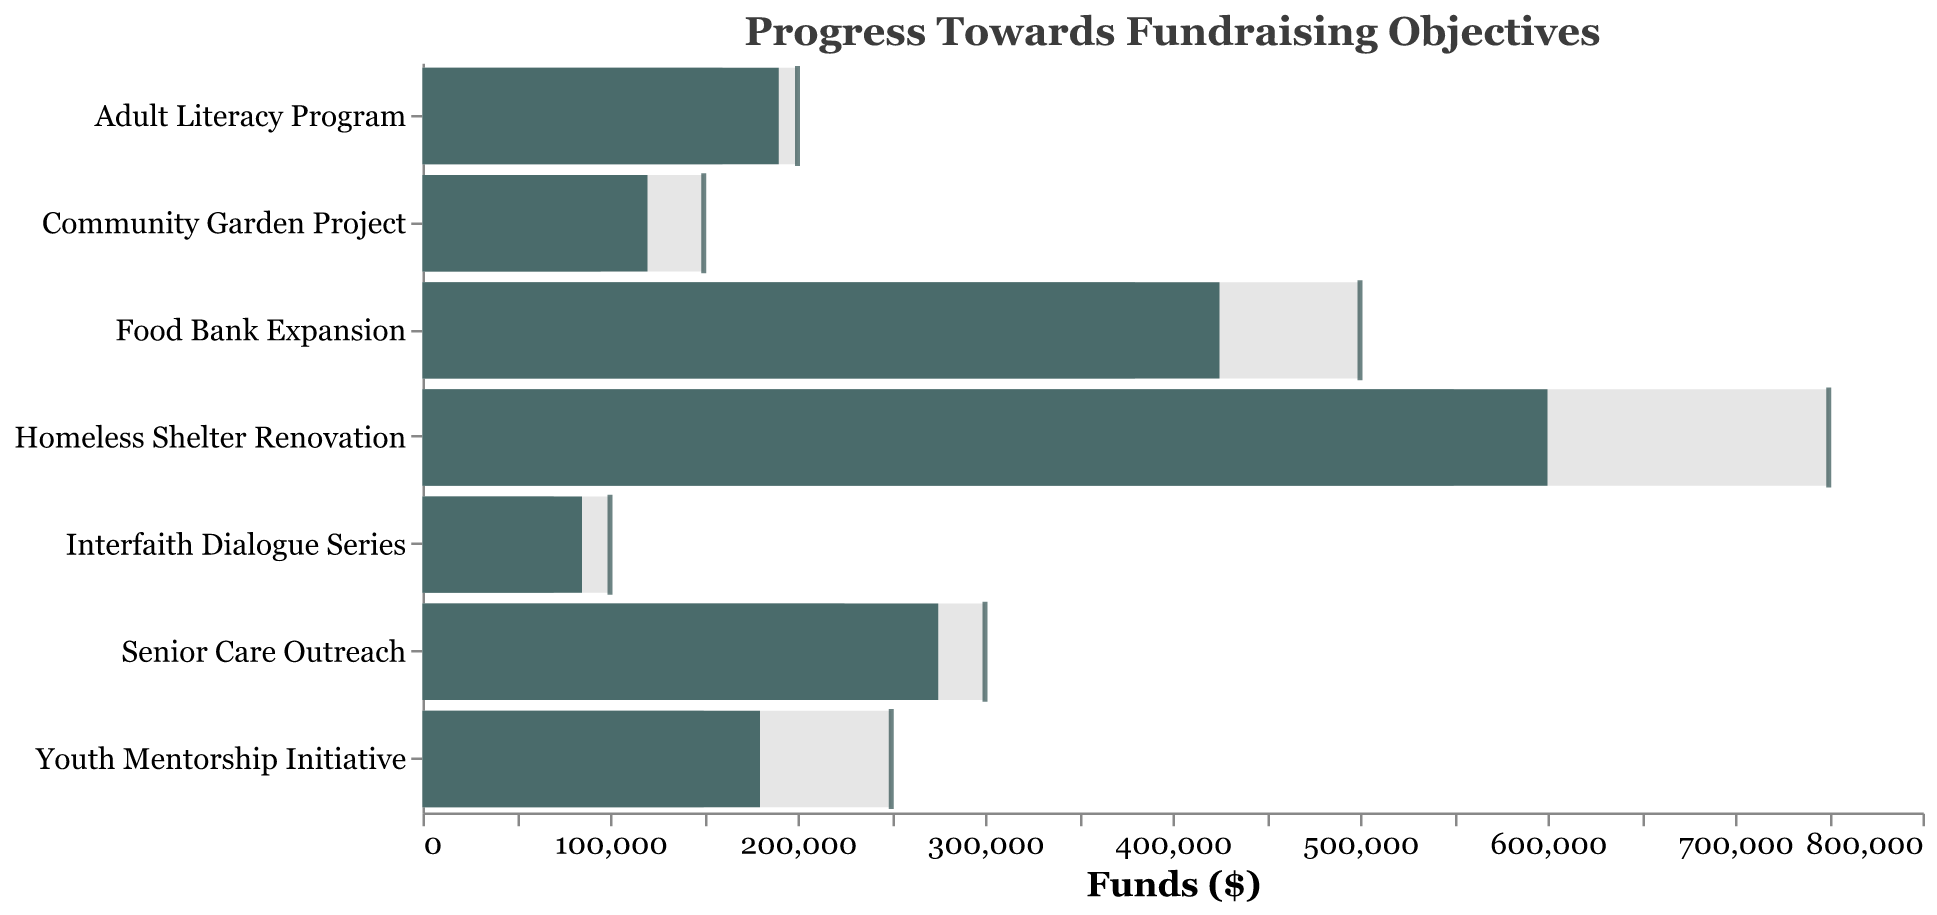What is the title of the chart? The title of the chart is displayed at the top and can be read directly.
Answer: Progress Towards Fundraising Objectives Which program has the highest fundraising target? By looking at the bars and ticks representing the targets, the highest target corresponds to the longest bar.
Answer: Homeless Shelter Renovation How does the current fundraising for the Senior Care Outreach compare to the previous year? The current fundraising amount is represented by the dark bar, while the previous year's amount is represented by the lighter bar.
Answer: Higher Which program is the closest to reaching its fundraising target? By comparing the lengths of the dark bars (current fundraising) to the ticks (targets), the program whose dark bar is closest to the tick is the closest to its target.
Answer: Adult Literacy Program What is the total fundraising target for all programs combined? Add up all the target values from the data provided. 500000 + 250000 + 300000 + 100000 + 750000 + 200000 + 150000 = 2,250,000
Answer: 2,250,000 By how much has the Youth Mentorship Initiative's fundraising increased compared to the previous year? Subtract the previous year's amount from the current amount: 180000 - 150000 = 30000
Answer: 30,000 Which program saw the largest increase in fundraising from the previous year? Compare the increase in each program by subtracting the previous year's amount from the current amount and finding the greatest difference: - Food Bank Expansion: 425000 - 380000 = 45000 - Youth Mentorship Initiative: 180000 - 150000 = 30000 - Senior Care Outreach: 275000 - 225000 = 50000 - Interfaith Dialogue Series: 85000 - 70000 = 15000 - Homeless Shelter Renovation: 600000 - 550000 = 50000 - Adult Literacy Program: 190000 - 160000 = 30000 - Community Garden Project: 120000 - 95000 = 25000 Senior Care Outreach and Homeless Shelter Renovation have the largest increase of 50000.
Answer: Senior Care Outreach and Homeless Shelter Renovation Which program has the lowest current fundraising amount? The shortest dark bar represents the lowest current fundraising amount.
Answer: Interfaith Dialogue Series What is the difference between the current and the target fundraising amount for the Community Garden Project? Subtract the current fundraising amount from the target amount: 150000 - 120000 = 30000
Answer: 30,000 Between the Food Bank Expansion and the Community Garden Project, which one is further behind in reaching its target fundraising goal in dollar amount? Subtract the current amount from the target for both programs and compare: - Food Bank Expansion: 500000 - 425000 = 75000 - Community Garden Project: 150000 - 120000 = 30000 75000 is greater than 30000.
Answer: Food Bank Expansion 